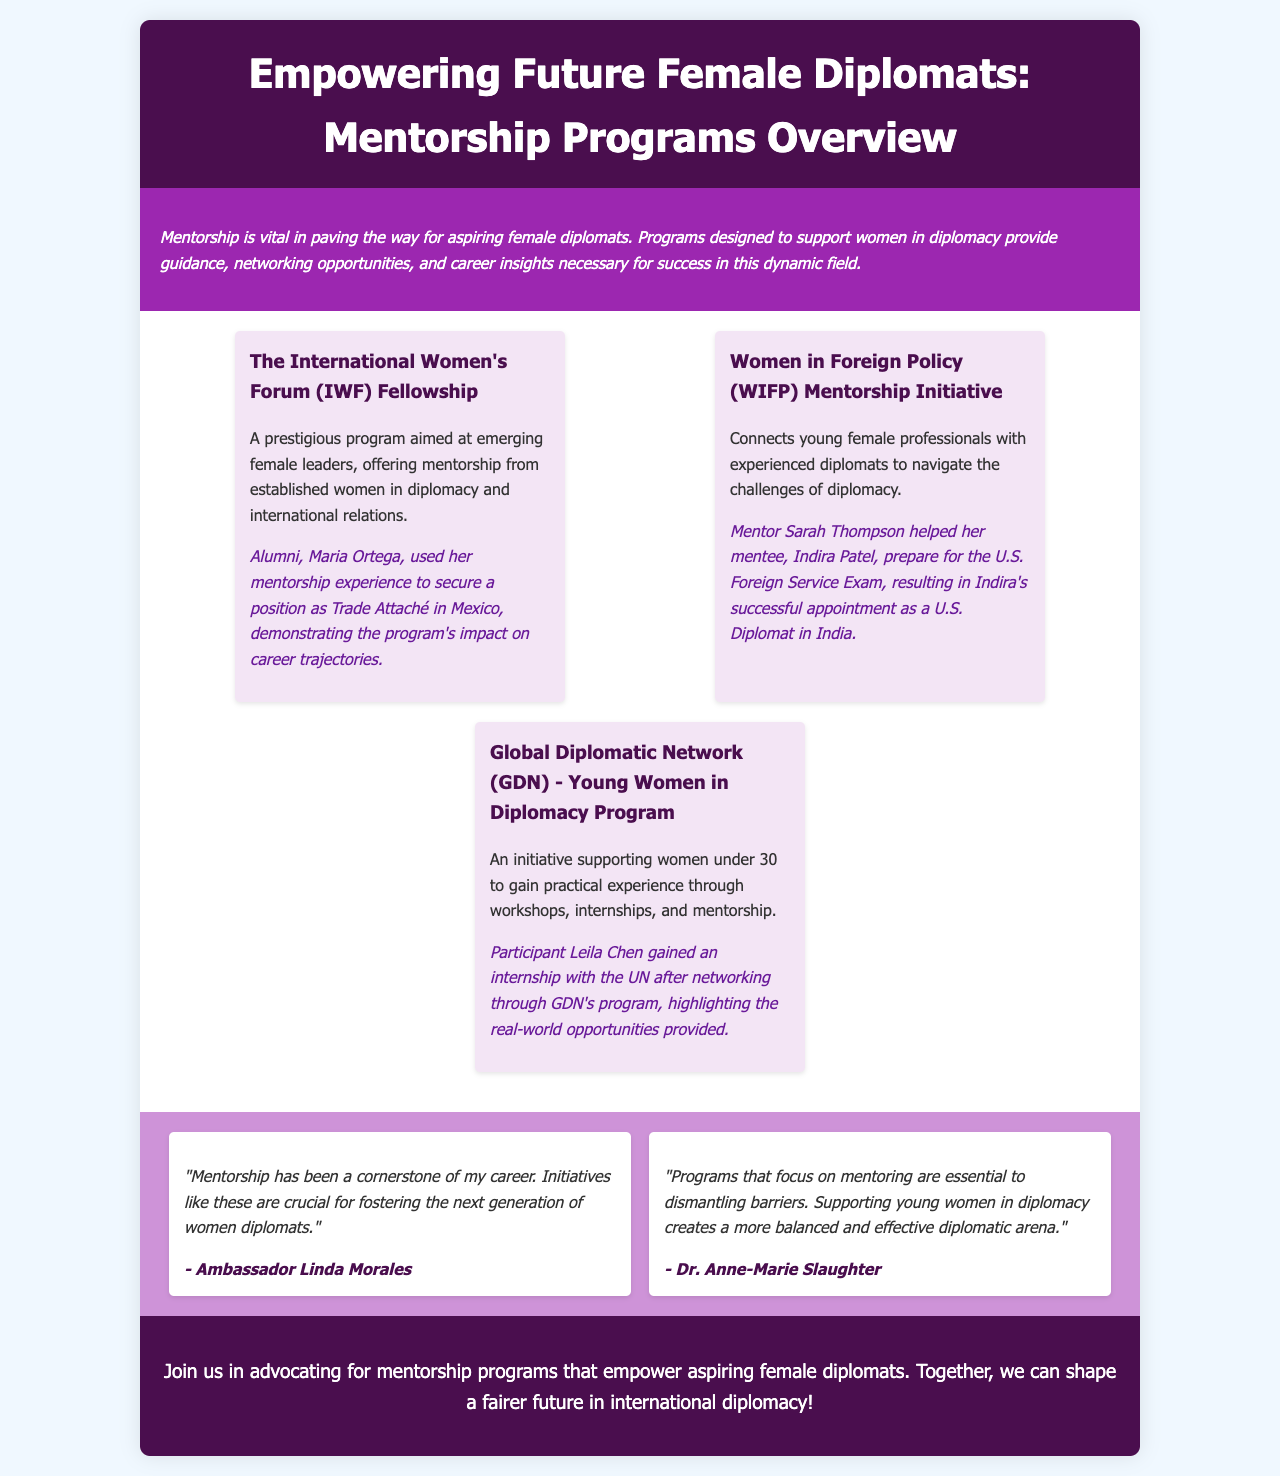What is the title of the brochure? The title of the brochure is stated at the top of the document.
Answer: Empowering Future Female Diplomats: Mentorship Programs Overview What is the color scheme used for the introduction section? The introduction section has a specific background color that is distinct from the rest of the brochure.
Answer: Purple Who is the mentor mentioned in the Women in Foreign Policy Mentorship Initiative? The document includes specific names related to mentorship programs.
Answer: Sarah Thompson What success story is shared from the International Women's Forum Fellowship? The document provides examples of how participants benefited from the programs.
Answer: Maria Ortega What age group does the Global Diplomatic Network target? The text outlines the demographics for the program.
Answer: Under 30 What is the central theme of the testimonials section? The testimonials express the importance of mentorship in diplomacy.
Answer: Importance of mentorship How does the brochure describe mentorship's role for aspiring female diplomats? The introduction outlines the significance of mentorship in the field.
Answer: Vital How many programs are detailed in the brochure? The brochure lists specific programs supporting women in diplomacy.
Answer: Three 